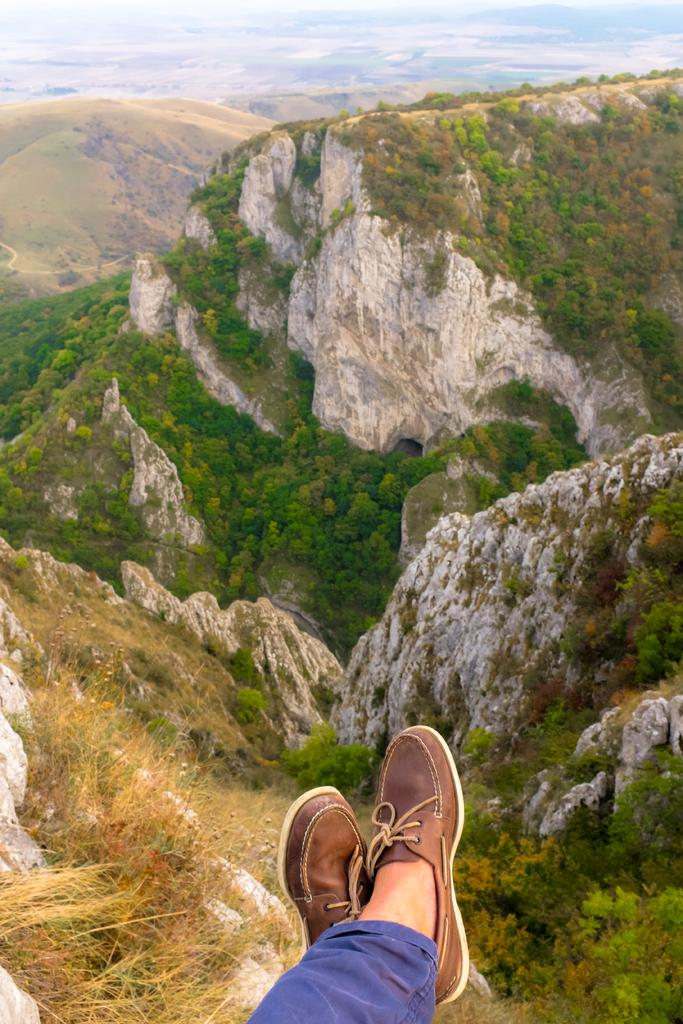What can be seen in the foreground of the image? There are two legs visible in the foreground of the image. What type of shoes are the legs wearing? The legs have brown shoes. What color are the pants on the legs? The legs have blue pants. What can be seen in the background of the image? There are hills and trees in the background of the image. What type of club is visible in the image? There is no club present in the image. What route are the legs taking in the image? The legs are not taking a route, as they are stationary in the image. 